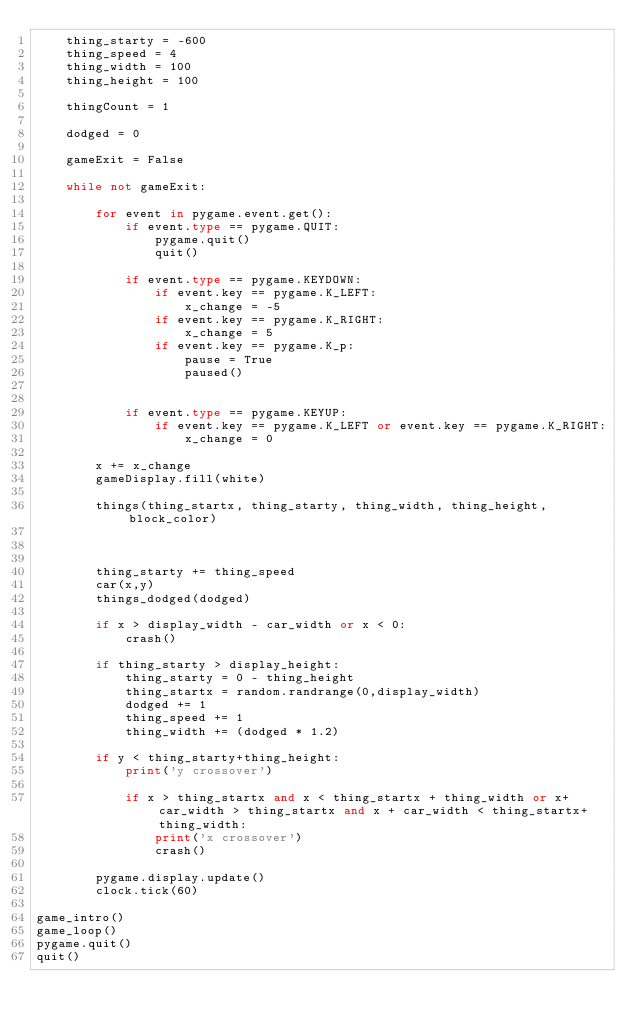Convert code to text. <code><loc_0><loc_0><loc_500><loc_500><_Python_>    thing_starty = -600
    thing_speed = 4
    thing_width = 100
    thing_height = 100
 
    thingCount = 1
 
    dodged = 0
 
    gameExit = False
 
    while not gameExit:
 
        for event in pygame.event.get():
            if event.type == pygame.QUIT:
                pygame.quit()
                quit()
 
            if event.type == pygame.KEYDOWN:
                if event.key == pygame.K_LEFT:
                    x_change = -5
                if event.key == pygame.K_RIGHT:
                    x_change = 5
                if event.key == pygame.K_p:
                    pause = True
                    paused()
                    
 
            if event.type == pygame.KEYUP:
                if event.key == pygame.K_LEFT or event.key == pygame.K_RIGHT:
                    x_change = 0
 
        x += x_change
        gameDisplay.fill(white)
 
        things(thing_startx, thing_starty, thing_width, thing_height, block_color)
 
 
        
        thing_starty += thing_speed
        car(x,y)
        things_dodged(dodged)
 
        if x > display_width - car_width or x < 0:
            crash()
 
        if thing_starty > display_height:
            thing_starty = 0 - thing_height
            thing_startx = random.randrange(0,display_width)
            dodged += 1
            thing_speed += 1
            thing_width += (dodged * 1.2)
 
        if y < thing_starty+thing_height:
            print('y crossover')
 
            if x > thing_startx and x < thing_startx + thing_width or x+car_width > thing_startx and x + car_width < thing_startx+thing_width:
                print('x crossover')
                crash()
        
        pygame.display.update()
        clock.tick(60)

game_intro()
game_loop()
pygame.quit()
quit()
</code> 